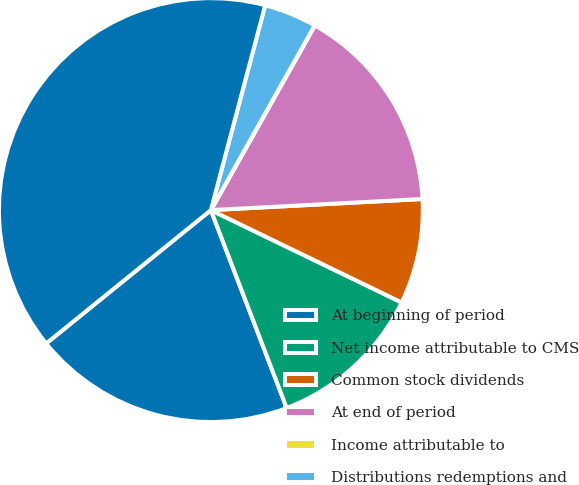Convert chart to OTSL. <chart><loc_0><loc_0><loc_500><loc_500><pie_chart><fcel>At beginning of period<fcel>Net income attributable to CMS<fcel>Common stock dividends<fcel>At end of period<fcel>Income attributable to<fcel>Distributions redemptions and<fcel>Total Equity at End of Period<nl><fcel>19.99%<fcel>12.0%<fcel>8.01%<fcel>16.0%<fcel>0.02%<fcel>4.02%<fcel>39.96%<nl></chart> 